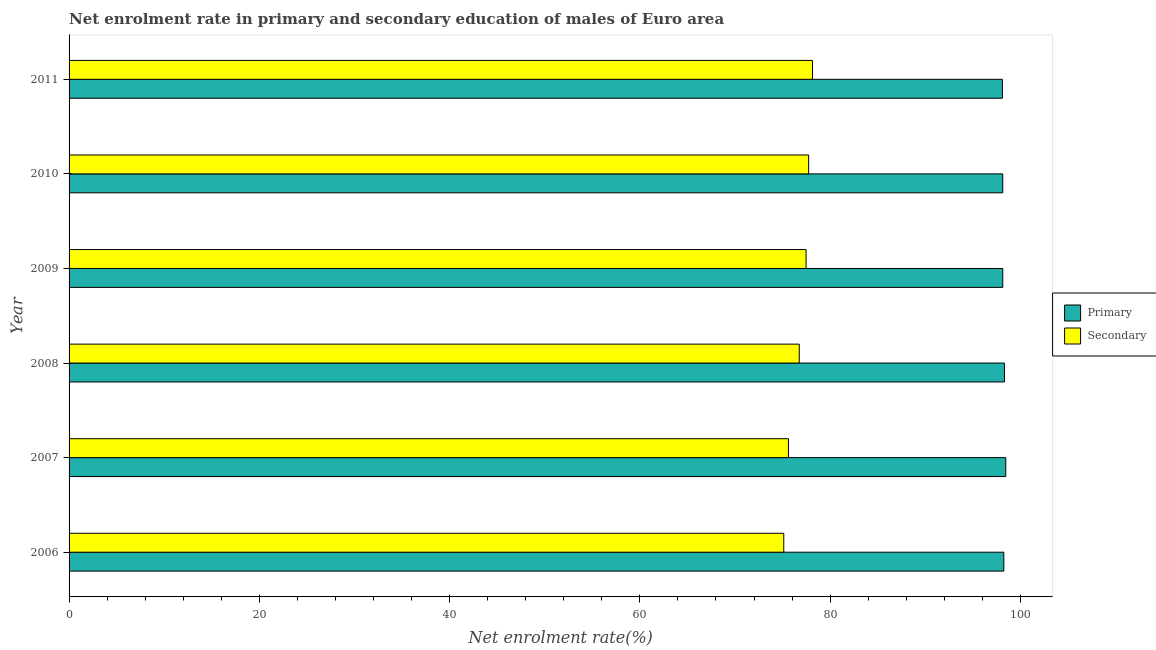How many different coloured bars are there?
Give a very brief answer. 2. Are the number of bars per tick equal to the number of legend labels?
Make the answer very short. Yes. Are the number of bars on each tick of the Y-axis equal?
Provide a succinct answer. Yes. How many bars are there on the 6th tick from the bottom?
Your answer should be very brief. 2. In how many cases, is the number of bars for a given year not equal to the number of legend labels?
Offer a terse response. 0. What is the enrollment rate in primary education in 2007?
Provide a short and direct response. 98.46. Across all years, what is the maximum enrollment rate in primary education?
Your response must be concise. 98.46. Across all years, what is the minimum enrollment rate in primary education?
Ensure brevity in your answer.  98.11. In which year was the enrollment rate in primary education maximum?
Give a very brief answer. 2007. In which year was the enrollment rate in primary education minimum?
Give a very brief answer. 2011. What is the total enrollment rate in secondary education in the graph?
Offer a terse response. 460.87. What is the difference between the enrollment rate in secondary education in 2008 and that in 2009?
Keep it short and to the point. -0.72. What is the difference between the enrollment rate in secondary education in 2006 and the enrollment rate in primary education in 2007?
Offer a terse response. -23.34. What is the average enrollment rate in secondary education per year?
Ensure brevity in your answer.  76.81. In the year 2011, what is the difference between the enrollment rate in secondary education and enrollment rate in primary education?
Give a very brief answer. -19.97. In how many years, is the enrollment rate in primary education greater than 96 %?
Provide a short and direct response. 6. What is the ratio of the enrollment rate in primary education in 2006 to that in 2010?
Your response must be concise. 1. What is the difference between the highest and the second highest enrollment rate in primary education?
Give a very brief answer. 0.14. What is the difference between the highest and the lowest enrollment rate in secondary education?
Provide a short and direct response. 3.02. What does the 1st bar from the top in 2011 represents?
Offer a very short reply. Secondary. What does the 1st bar from the bottom in 2009 represents?
Ensure brevity in your answer.  Primary. Are all the bars in the graph horizontal?
Your answer should be compact. Yes. How many years are there in the graph?
Keep it short and to the point. 6. What is the difference between two consecutive major ticks on the X-axis?
Your response must be concise. 20. Does the graph contain any zero values?
Offer a terse response. No. Where does the legend appear in the graph?
Your answer should be compact. Center right. How many legend labels are there?
Your answer should be very brief. 2. What is the title of the graph?
Give a very brief answer. Net enrolment rate in primary and secondary education of males of Euro area. What is the label or title of the X-axis?
Keep it short and to the point. Net enrolment rate(%). What is the label or title of the Y-axis?
Keep it short and to the point. Year. What is the Net enrolment rate(%) of Primary in 2006?
Offer a very short reply. 98.26. What is the Net enrolment rate(%) in Secondary in 2006?
Provide a succinct answer. 75.13. What is the Net enrolment rate(%) of Primary in 2007?
Provide a succinct answer. 98.46. What is the Net enrolment rate(%) in Secondary in 2007?
Provide a succinct answer. 75.62. What is the Net enrolment rate(%) in Primary in 2008?
Your answer should be compact. 98.33. What is the Net enrolment rate(%) of Secondary in 2008?
Make the answer very short. 76.76. What is the Net enrolment rate(%) of Primary in 2009?
Give a very brief answer. 98.15. What is the Net enrolment rate(%) in Secondary in 2009?
Give a very brief answer. 77.47. What is the Net enrolment rate(%) of Primary in 2010?
Provide a succinct answer. 98.15. What is the Net enrolment rate(%) in Secondary in 2010?
Offer a very short reply. 77.74. What is the Net enrolment rate(%) of Primary in 2011?
Offer a very short reply. 98.11. What is the Net enrolment rate(%) of Secondary in 2011?
Your answer should be very brief. 78.15. Across all years, what is the maximum Net enrolment rate(%) of Primary?
Give a very brief answer. 98.46. Across all years, what is the maximum Net enrolment rate(%) in Secondary?
Your answer should be compact. 78.15. Across all years, what is the minimum Net enrolment rate(%) of Primary?
Your answer should be compact. 98.11. Across all years, what is the minimum Net enrolment rate(%) of Secondary?
Keep it short and to the point. 75.13. What is the total Net enrolment rate(%) in Primary in the graph?
Your answer should be very brief. 589.46. What is the total Net enrolment rate(%) of Secondary in the graph?
Provide a succinct answer. 460.87. What is the difference between the Net enrolment rate(%) in Primary in 2006 and that in 2007?
Keep it short and to the point. -0.2. What is the difference between the Net enrolment rate(%) in Secondary in 2006 and that in 2007?
Your answer should be very brief. -0.49. What is the difference between the Net enrolment rate(%) of Primary in 2006 and that in 2008?
Ensure brevity in your answer.  -0.07. What is the difference between the Net enrolment rate(%) in Secondary in 2006 and that in 2008?
Your response must be concise. -1.63. What is the difference between the Net enrolment rate(%) of Secondary in 2006 and that in 2009?
Offer a very short reply. -2.35. What is the difference between the Net enrolment rate(%) in Primary in 2006 and that in 2010?
Offer a very short reply. 0.11. What is the difference between the Net enrolment rate(%) in Secondary in 2006 and that in 2010?
Ensure brevity in your answer.  -2.61. What is the difference between the Net enrolment rate(%) in Primary in 2006 and that in 2011?
Keep it short and to the point. 0.15. What is the difference between the Net enrolment rate(%) of Secondary in 2006 and that in 2011?
Offer a very short reply. -3.02. What is the difference between the Net enrolment rate(%) in Primary in 2007 and that in 2008?
Your response must be concise. 0.14. What is the difference between the Net enrolment rate(%) of Secondary in 2007 and that in 2008?
Offer a very short reply. -1.14. What is the difference between the Net enrolment rate(%) of Primary in 2007 and that in 2009?
Offer a very short reply. 0.31. What is the difference between the Net enrolment rate(%) in Secondary in 2007 and that in 2009?
Offer a terse response. -1.86. What is the difference between the Net enrolment rate(%) of Primary in 2007 and that in 2010?
Give a very brief answer. 0.31. What is the difference between the Net enrolment rate(%) in Secondary in 2007 and that in 2010?
Offer a very short reply. -2.12. What is the difference between the Net enrolment rate(%) in Primary in 2007 and that in 2011?
Your answer should be very brief. 0.35. What is the difference between the Net enrolment rate(%) in Secondary in 2007 and that in 2011?
Keep it short and to the point. -2.53. What is the difference between the Net enrolment rate(%) in Primary in 2008 and that in 2009?
Your answer should be compact. 0.18. What is the difference between the Net enrolment rate(%) of Secondary in 2008 and that in 2009?
Offer a very short reply. -0.72. What is the difference between the Net enrolment rate(%) of Primary in 2008 and that in 2010?
Make the answer very short. 0.18. What is the difference between the Net enrolment rate(%) of Secondary in 2008 and that in 2010?
Keep it short and to the point. -0.99. What is the difference between the Net enrolment rate(%) in Primary in 2008 and that in 2011?
Offer a very short reply. 0.22. What is the difference between the Net enrolment rate(%) in Secondary in 2008 and that in 2011?
Offer a terse response. -1.39. What is the difference between the Net enrolment rate(%) in Secondary in 2009 and that in 2010?
Your answer should be very brief. -0.27. What is the difference between the Net enrolment rate(%) of Primary in 2009 and that in 2011?
Your answer should be compact. 0.04. What is the difference between the Net enrolment rate(%) of Secondary in 2009 and that in 2011?
Provide a short and direct response. -0.67. What is the difference between the Net enrolment rate(%) in Primary in 2010 and that in 2011?
Your answer should be compact. 0.04. What is the difference between the Net enrolment rate(%) in Secondary in 2010 and that in 2011?
Make the answer very short. -0.4. What is the difference between the Net enrolment rate(%) of Primary in 2006 and the Net enrolment rate(%) of Secondary in 2007?
Offer a terse response. 22.64. What is the difference between the Net enrolment rate(%) in Primary in 2006 and the Net enrolment rate(%) in Secondary in 2008?
Your answer should be compact. 21.5. What is the difference between the Net enrolment rate(%) in Primary in 2006 and the Net enrolment rate(%) in Secondary in 2009?
Your response must be concise. 20.79. What is the difference between the Net enrolment rate(%) in Primary in 2006 and the Net enrolment rate(%) in Secondary in 2010?
Provide a succinct answer. 20.52. What is the difference between the Net enrolment rate(%) of Primary in 2006 and the Net enrolment rate(%) of Secondary in 2011?
Your answer should be very brief. 20.11. What is the difference between the Net enrolment rate(%) in Primary in 2007 and the Net enrolment rate(%) in Secondary in 2008?
Your response must be concise. 21.71. What is the difference between the Net enrolment rate(%) in Primary in 2007 and the Net enrolment rate(%) in Secondary in 2009?
Make the answer very short. 20.99. What is the difference between the Net enrolment rate(%) in Primary in 2007 and the Net enrolment rate(%) in Secondary in 2010?
Make the answer very short. 20.72. What is the difference between the Net enrolment rate(%) in Primary in 2007 and the Net enrolment rate(%) in Secondary in 2011?
Your response must be concise. 20.32. What is the difference between the Net enrolment rate(%) of Primary in 2008 and the Net enrolment rate(%) of Secondary in 2009?
Provide a short and direct response. 20.85. What is the difference between the Net enrolment rate(%) of Primary in 2008 and the Net enrolment rate(%) of Secondary in 2010?
Provide a short and direct response. 20.58. What is the difference between the Net enrolment rate(%) of Primary in 2008 and the Net enrolment rate(%) of Secondary in 2011?
Provide a short and direct response. 20.18. What is the difference between the Net enrolment rate(%) in Primary in 2009 and the Net enrolment rate(%) in Secondary in 2010?
Your answer should be compact. 20.41. What is the difference between the Net enrolment rate(%) of Primary in 2009 and the Net enrolment rate(%) of Secondary in 2011?
Your answer should be compact. 20. What is the difference between the Net enrolment rate(%) of Primary in 2010 and the Net enrolment rate(%) of Secondary in 2011?
Keep it short and to the point. 20. What is the average Net enrolment rate(%) of Primary per year?
Your answer should be very brief. 98.24. What is the average Net enrolment rate(%) of Secondary per year?
Offer a very short reply. 76.81. In the year 2006, what is the difference between the Net enrolment rate(%) in Primary and Net enrolment rate(%) in Secondary?
Offer a very short reply. 23.13. In the year 2007, what is the difference between the Net enrolment rate(%) in Primary and Net enrolment rate(%) in Secondary?
Your response must be concise. 22.84. In the year 2008, what is the difference between the Net enrolment rate(%) of Primary and Net enrolment rate(%) of Secondary?
Offer a terse response. 21.57. In the year 2009, what is the difference between the Net enrolment rate(%) in Primary and Net enrolment rate(%) in Secondary?
Your response must be concise. 20.68. In the year 2010, what is the difference between the Net enrolment rate(%) of Primary and Net enrolment rate(%) of Secondary?
Your response must be concise. 20.41. In the year 2011, what is the difference between the Net enrolment rate(%) of Primary and Net enrolment rate(%) of Secondary?
Provide a short and direct response. 19.97. What is the ratio of the Net enrolment rate(%) in Primary in 2006 to that in 2007?
Your response must be concise. 1. What is the ratio of the Net enrolment rate(%) in Primary in 2006 to that in 2008?
Ensure brevity in your answer.  1. What is the ratio of the Net enrolment rate(%) of Secondary in 2006 to that in 2008?
Give a very brief answer. 0.98. What is the ratio of the Net enrolment rate(%) in Secondary in 2006 to that in 2009?
Give a very brief answer. 0.97. What is the ratio of the Net enrolment rate(%) in Primary in 2006 to that in 2010?
Give a very brief answer. 1. What is the ratio of the Net enrolment rate(%) of Secondary in 2006 to that in 2010?
Ensure brevity in your answer.  0.97. What is the ratio of the Net enrolment rate(%) in Primary in 2006 to that in 2011?
Provide a short and direct response. 1. What is the ratio of the Net enrolment rate(%) in Secondary in 2006 to that in 2011?
Keep it short and to the point. 0.96. What is the ratio of the Net enrolment rate(%) in Secondary in 2007 to that in 2008?
Provide a succinct answer. 0.99. What is the ratio of the Net enrolment rate(%) of Secondary in 2007 to that in 2009?
Ensure brevity in your answer.  0.98. What is the ratio of the Net enrolment rate(%) of Secondary in 2007 to that in 2010?
Your answer should be very brief. 0.97. What is the ratio of the Net enrolment rate(%) in Primary in 2007 to that in 2011?
Your answer should be very brief. 1. What is the ratio of the Net enrolment rate(%) in Secondary in 2007 to that in 2011?
Offer a very short reply. 0.97. What is the ratio of the Net enrolment rate(%) of Primary in 2008 to that in 2009?
Your answer should be compact. 1. What is the ratio of the Net enrolment rate(%) in Secondary in 2008 to that in 2009?
Your answer should be compact. 0.99. What is the ratio of the Net enrolment rate(%) in Primary in 2008 to that in 2010?
Offer a terse response. 1. What is the ratio of the Net enrolment rate(%) in Secondary in 2008 to that in 2010?
Provide a short and direct response. 0.99. What is the ratio of the Net enrolment rate(%) of Primary in 2008 to that in 2011?
Provide a short and direct response. 1. What is the ratio of the Net enrolment rate(%) in Secondary in 2008 to that in 2011?
Offer a terse response. 0.98. What is the ratio of the Net enrolment rate(%) in Primary in 2009 to that in 2011?
Ensure brevity in your answer.  1. What is the ratio of the Net enrolment rate(%) of Primary in 2010 to that in 2011?
Provide a short and direct response. 1. What is the difference between the highest and the second highest Net enrolment rate(%) of Primary?
Your answer should be very brief. 0.14. What is the difference between the highest and the second highest Net enrolment rate(%) of Secondary?
Your answer should be compact. 0.4. What is the difference between the highest and the lowest Net enrolment rate(%) of Primary?
Provide a succinct answer. 0.35. What is the difference between the highest and the lowest Net enrolment rate(%) of Secondary?
Your response must be concise. 3.02. 